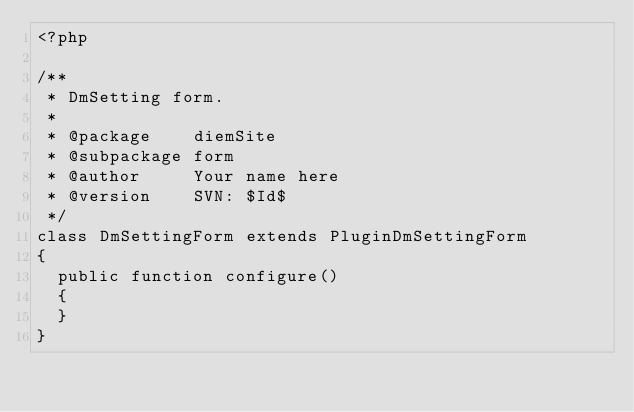<code> <loc_0><loc_0><loc_500><loc_500><_PHP_><?php

/**
 * DmSetting form.
 *
 * @package    diemSite
 * @subpackage form
 * @author     Your name here
 * @version    SVN: $Id$
 */
class DmSettingForm extends PluginDmSettingForm
{
  public function configure()
  {
  }
}</code> 